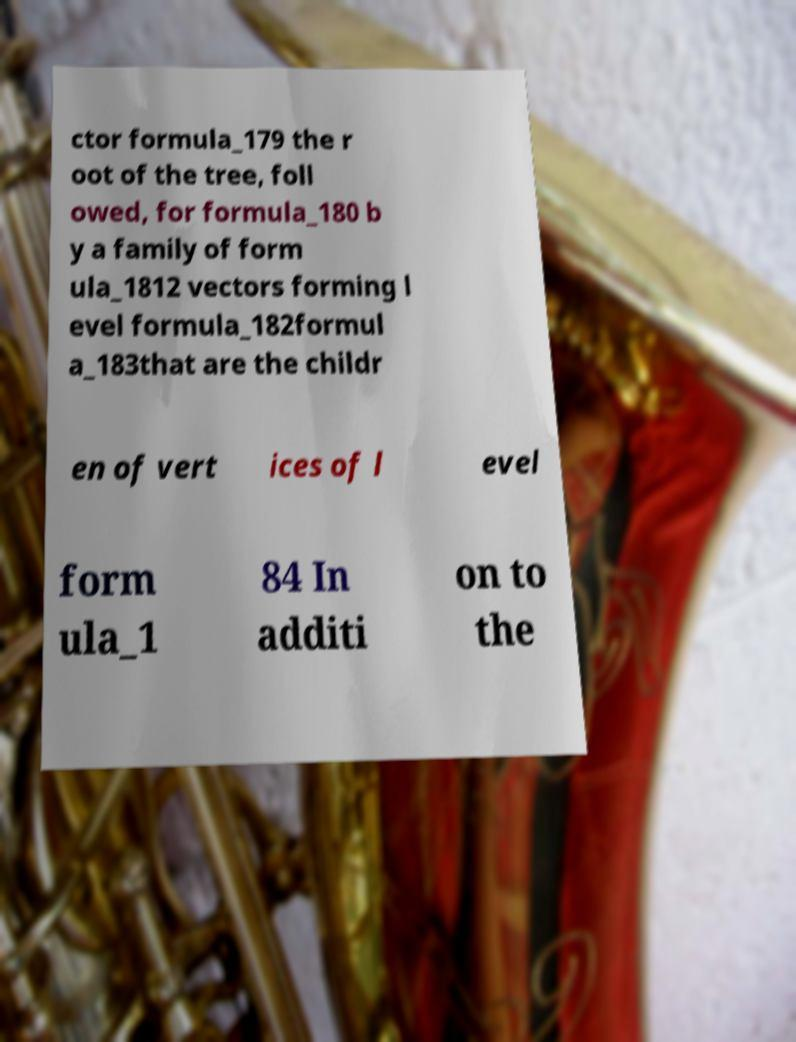Please read and relay the text visible in this image. What does it say? ctor formula_179 the r oot of the tree, foll owed, for formula_180 b y a family of form ula_1812 vectors forming l evel formula_182formul a_183that are the childr en of vert ices of l evel form ula_1 84 In additi on to the 